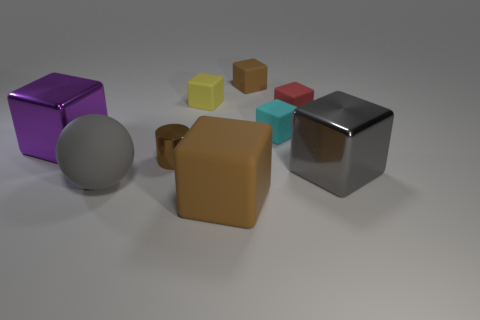Are there more shiny cylinders that are behind the yellow block than tiny brown rubber things on the right side of the large brown object? After examining the image carefully, it appears that there are two shiny cylinders behind the yellow block and no tiny brown objects located on the right side of the large brown object. Therefore, there is a greater number of shiny cylinders behind the yellow block. 